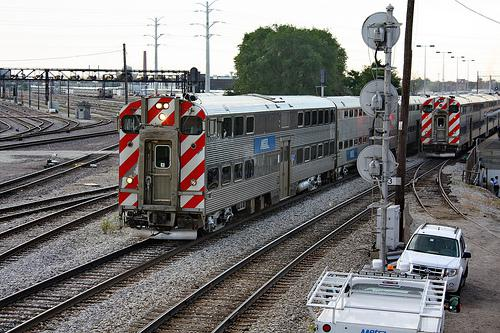Question: what is this photo of?
Choices:
A. Trains.
B. Cars.
C. Planes.
D. Boats.
Answer with the letter. Answer: A Question: where is the suv?
Choices:
A. Next to a brick building.
B. By the railroad crossing sign.
C. On a low bridge.
D. At the entrance to the parking garage.
Answer with the letter. Answer: B Question: when did the train start moving?
Choices:
A. What the light turned green.
B. When it was safe.
C. When it was clear.
D. Whenever it wanted.
Answer with the letter. Answer: A Question: why does the train have its lights on?
Choices:
A. It's night time.
B. So people can see it.
C. It is a law that they must always be on.
D. It is raining and overcast.
Answer with the letter. Answer: B 